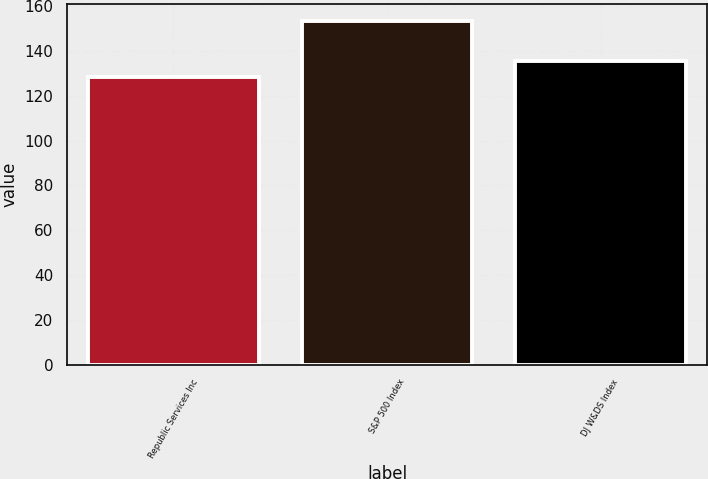Convert chart. <chart><loc_0><loc_0><loc_500><loc_500><bar_chart><fcel>Republic Services Inc<fcel>S&P 500 Index<fcel>DJ W&DS Index<nl><fcel>128.3<fcel>153.57<fcel>135.56<nl></chart> 